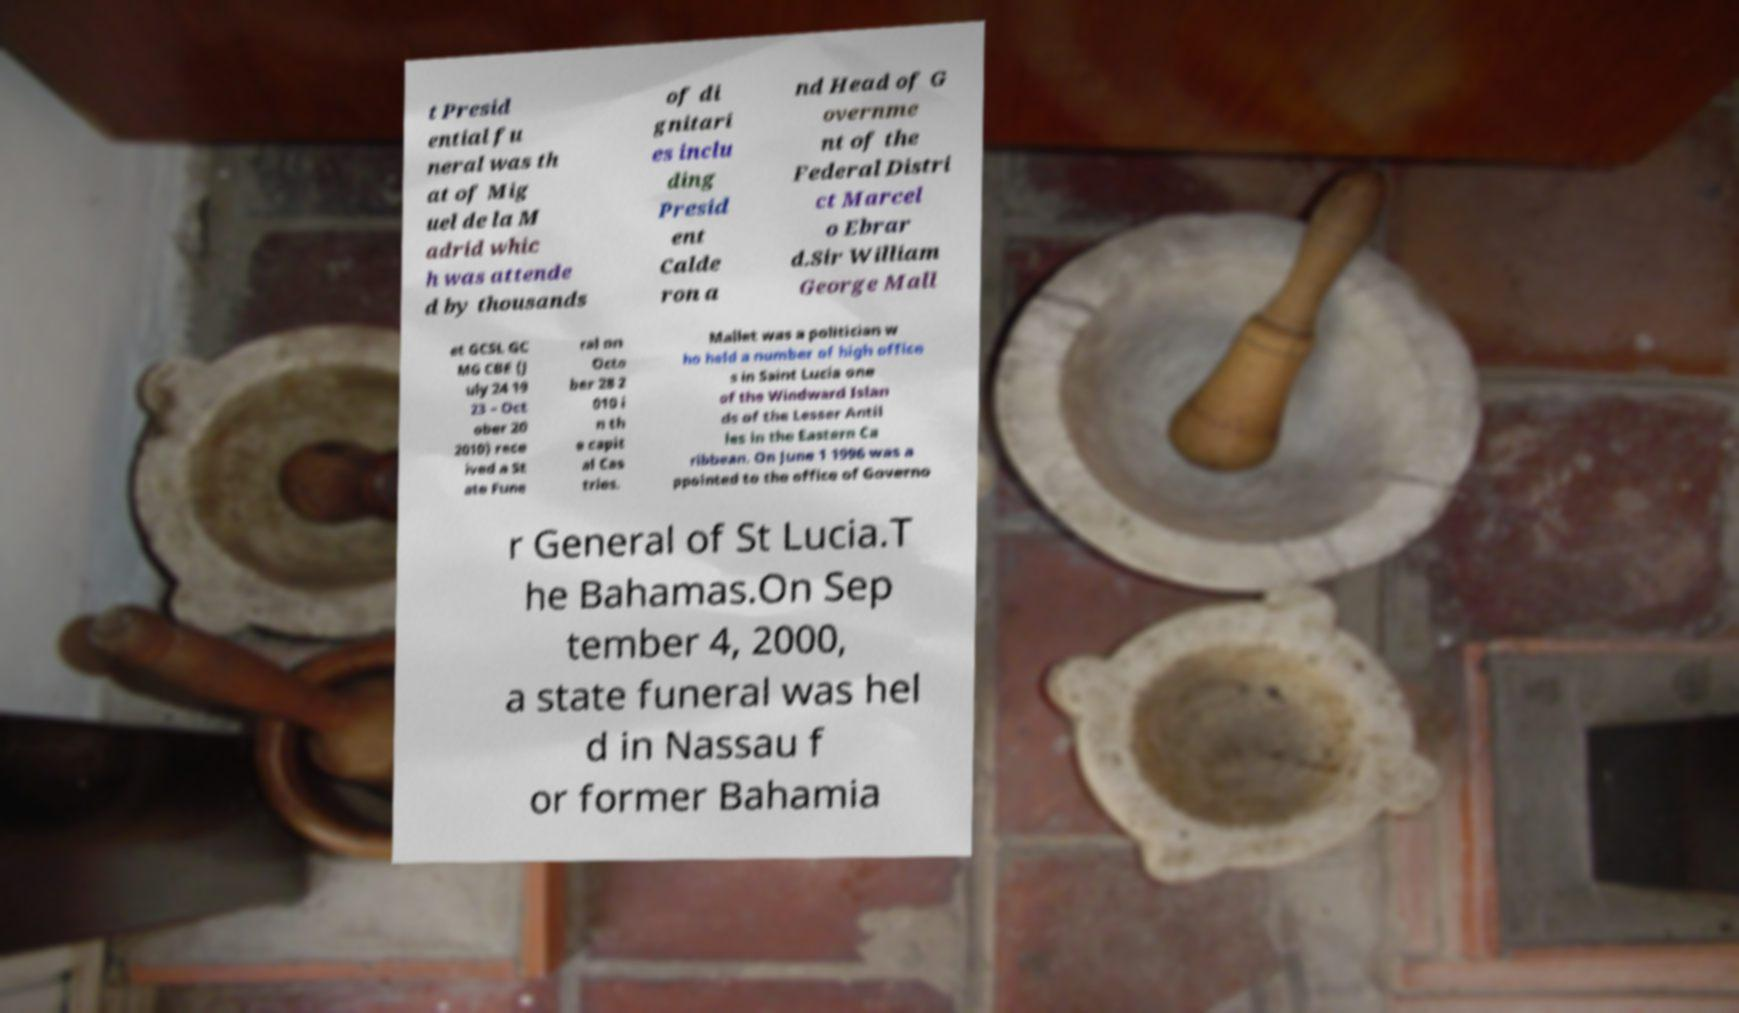Can you read and provide the text displayed in the image?This photo seems to have some interesting text. Can you extract and type it out for me? t Presid ential fu neral was th at of Mig uel de la M adrid whic h was attende d by thousands of di gnitari es inclu ding Presid ent Calde ron a nd Head of G overnme nt of the Federal Distri ct Marcel o Ebrar d.Sir William George Mall et GCSL GC MG CBE (J uly 24 19 23 – Oct ober 20 2010) rece ived a St ate Fune ral on Octo ber 28 2 010 i n th e capit al Cas tries. Mallet was a politician w ho held a number of high office s in Saint Lucia one of the Windward Islan ds of the Lesser Antil les in the Eastern Ca ribbean. On June 1 1996 was a ppointed to the office of Governo r General of St Lucia.T he Bahamas.On Sep tember 4, 2000, a state funeral was hel d in Nassau f or former Bahamia 